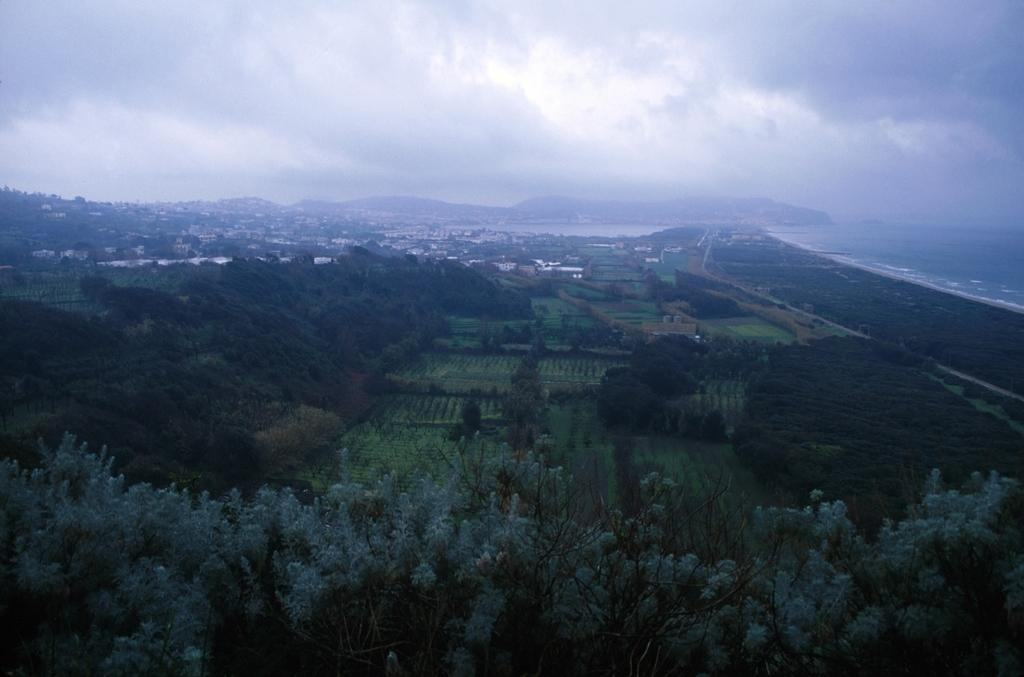What type of natural elements can be seen in the image? There are trees and water visible in the image. What type of landscape is visible in the image? There is land visible in the image, along with houses, mountains, and a cloudy sky in the background. Where are the tomatoes growing in the image? There are no tomatoes present in the image. What type of things can be seen in the cemetery in the image? There is no cemetery present in the image. 